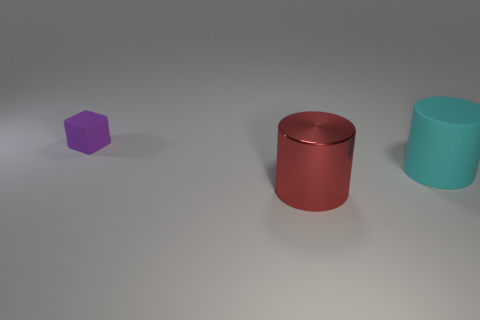Are there any other things that have the same material as the cyan thing?
Offer a terse response. Yes. Are there any tiny purple things on the right side of the big cyan rubber cylinder that is behind the cylinder that is in front of the big matte cylinder?
Provide a short and direct response. No. What is the shape of the metal object that is the same size as the cyan rubber cylinder?
Your answer should be very brief. Cylinder. How many other objects are the same color as the tiny matte object?
Give a very brief answer. 0. What is the small object made of?
Offer a terse response. Rubber. How many other things are the same material as the big red thing?
Offer a terse response. 0. What size is the object that is both behind the red metal thing and in front of the small purple object?
Provide a succinct answer. Large. What is the shape of the large thing that is behind the large object that is to the left of the large rubber thing?
Offer a very short reply. Cylinder. Are there any other things that have the same shape as the red object?
Your response must be concise. Yes. Is the number of red metallic cylinders that are on the right side of the large matte object the same as the number of large red metallic cubes?
Make the answer very short. Yes. 